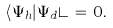<formula> <loc_0><loc_0><loc_500><loc_500>\langle \Psi _ { h } | \Psi _ { d } \rangle \, = \, 0 .</formula> 